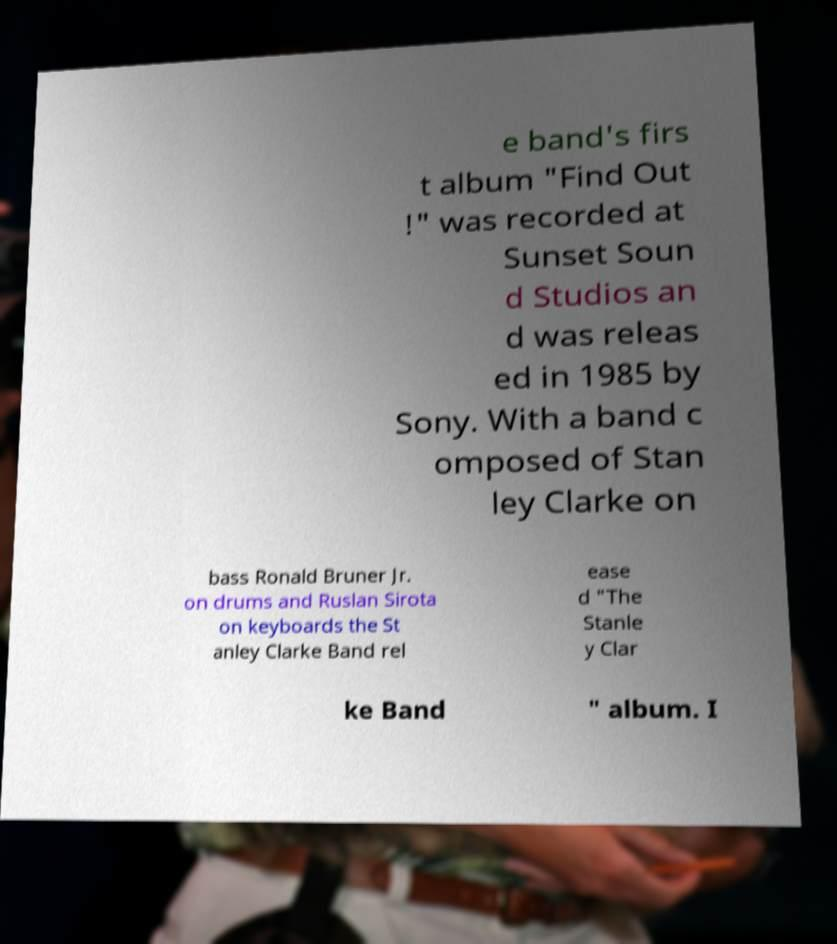Can you accurately transcribe the text from the provided image for me? e band's firs t album "Find Out !" was recorded at Sunset Soun d Studios an d was releas ed in 1985 by Sony. With a band c omposed of Stan ley Clarke on bass Ronald Bruner Jr. on drums and Ruslan Sirota on keyboards the St anley Clarke Band rel ease d "The Stanle y Clar ke Band " album. I 